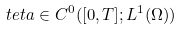<formula> <loc_0><loc_0><loc_500><loc_500>\ t e t a \in C ^ { 0 } ( [ 0 , T ] ; L ^ { 1 } ( \Omega ) )</formula> 